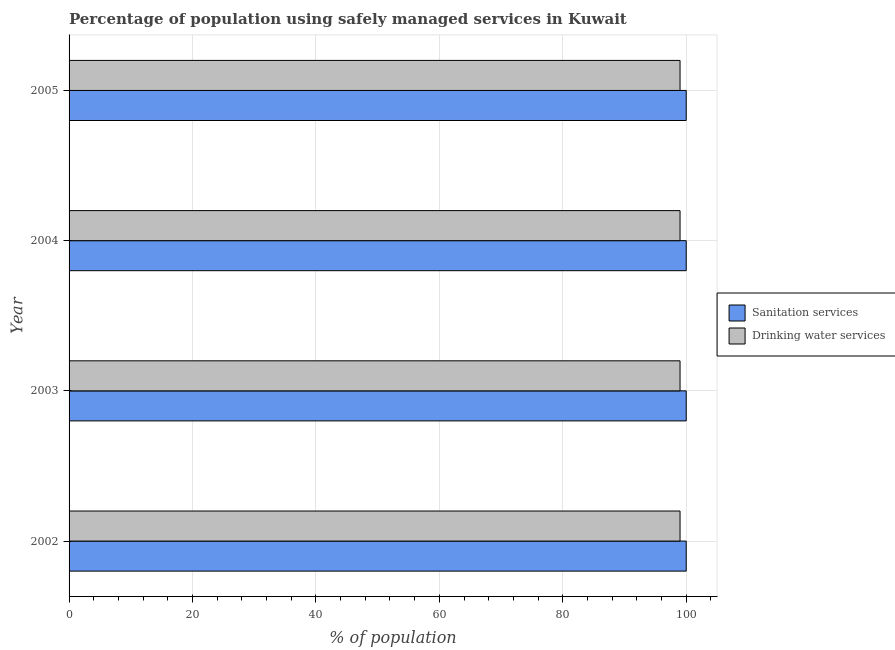How many different coloured bars are there?
Your response must be concise. 2. Are the number of bars on each tick of the Y-axis equal?
Keep it short and to the point. Yes. What is the percentage of population who used sanitation services in 2003?
Make the answer very short. 100. Across all years, what is the maximum percentage of population who used sanitation services?
Provide a short and direct response. 100. Across all years, what is the minimum percentage of population who used drinking water services?
Make the answer very short. 99. In which year was the percentage of population who used drinking water services minimum?
Give a very brief answer. 2002. What is the total percentage of population who used drinking water services in the graph?
Make the answer very short. 396. What is the difference between the percentage of population who used sanitation services in 2003 and that in 2004?
Make the answer very short. 0. What is the difference between the percentage of population who used drinking water services in 2004 and the percentage of population who used sanitation services in 2003?
Your answer should be very brief. -1. What is the average percentage of population who used drinking water services per year?
Your response must be concise. 99. In the year 2004, what is the difference between the percentage of population who used drinking water services and percentage of population who used sanitation services?
Offer a very short reply. -1. Is the difference between the percentage of population who used drinking water services in 2002 and 2005 greater than the difference between the percentage of population who used sanitation services in 2002 and 2005?
Your response must be concise. No. What is the difference between the highest and the second highest percentage of population who used drinking water services?
Provide a succinct answer. 0. What is the difference between the highest and the lowest percentage of population who used sanitation services?
Your response must be concise. 0. In how many years, is the percentage of population who used drinking water services greater than the average percentage of population who used drinking water services taken over all years?
Your answer should be compact. 0. What does the 1st bar from the top in 2004 represents?
Make the answer very short. Drinking water services. What does the 1st bar from the bottom in 2002 represents?
Keep it short and to the point. Sanitation services. How many years are there in the graph?
Keep it short and to the point. 4. Does the graph contain any zero values?
Your answer should be very brief. No. How many legend labels are there?
Keep it short and to the point. 2. How are the legend labels stacked?
Your answer should be very brief. Vertical. What is the title of the graph?
Provide a short and direct response. Percentage of population using safely managed services in Kuwait. What is the label or title of the X-axis?
Your answer should be very brief. % of population. What is the % of population in Sanitation services in 2003?
Offer a very short reply. 100. What is the % of population in Sanitation services in 2004?
Give a very brief answer. 100. What is the % of population of Drinking water services in 2004?
Keep it short and to the point. 99. What is the % of population in Sanitation services in 2005?
Ensure brevity in your answer.  100. Across all years, what is the maximum % of population of Drinking water services?
Ensure brevity in your answer.  99. Across all years, what is the minimum % of population of Drinking water services?
Keep it short and to the point. 99. What is the total % of population in Drinking water services in the graph?
Provide a succinct answer. 396. What is the difference between the % of population in Drinking water services in 2002 and that in 2003?
Your response must be concise. 0. What is the difference between the % of population of Drinking water services in 2002 and that in 2004?
Provide a short and direct response. 0. What is the difference between the % of population of Sanitation services in 2002 and that in 2005?
Provide a short and direct response. 0. What is the difference between the % of population in Sanitation services in 2003 and that in 2004?
Offer a very short reply. 0. What is the difference between the % of population in Sanitation services in 2003 and that in 2005?
Your answer should be compact. 0. What is the difference between the % of population in Drinking water services in 2004 and that in 2005?
Offer a terse response. 0. What is the difference between the % of population in Sanitation services in 2002 and the % of population in Drinking water services in 2004?
Give a very brief answer. 1. What is the difference between the % of population of Sanitation services in 2002 and the % of population of Drinking water services in 2005?
Your response must be concise. 1. What is the difference between the % of population of Sanitation services in 2003 and the % of population of Drinking water services in 2004?
Offer a very short reply. 1. What is the difference between the % of population of Sanitation services in 2003 and the % of population of Drinking water services in 2005?
Offer a very short reply. 1. What is the average % of population in Sanitation services per year?
Your response must be concise. 100. What is the average % of population of Drinking water services per year?
Your answer should be very brief. 99. In the year 2003, what is the difference between the % of population of Sanitation services and % of population of Drinking water services?
Your answer should be very brief. 1. In the year 2004, what is the difference between the % of population of Sanitation services and % of population of Drinking water services?
Provide a succinct answer. 1. What is the ratio of the % of population of Sanitation services in 2002 to that in 2004?
Ensure brevity in your answer.  1. What is the ratio of the % of population of Drinking water services in 2002 to that in 2004?
Ensure brevity in your answer.  1. What is the ratio of the % of population in Sanitation services in 2002 to that in 2005?
Provide a succinct answer. 1. What is the ratio of the % of population in Sanitation services in 2003 to that in 2004?
Keep it short and to the point. 1. What is the ratio of the % of population in Drinking water services in 2003 to that in 2005?
Your answer should be very brief. 1. What is the ratio of the % of population of Sanitation services in 2004 to that in 2005?
Your answer should be compact. 1. What is the ratio of the % of population in Drinking water services in 2004 to that in 2005?
Make the answer very short. 1. What is the difference between the highest and the second highest % of population in Drinking water services?
Make the answer very short. 0. What is the difference between the highest and the lowest % of population of Drinking water services?
Offer a very short reply. 0. 